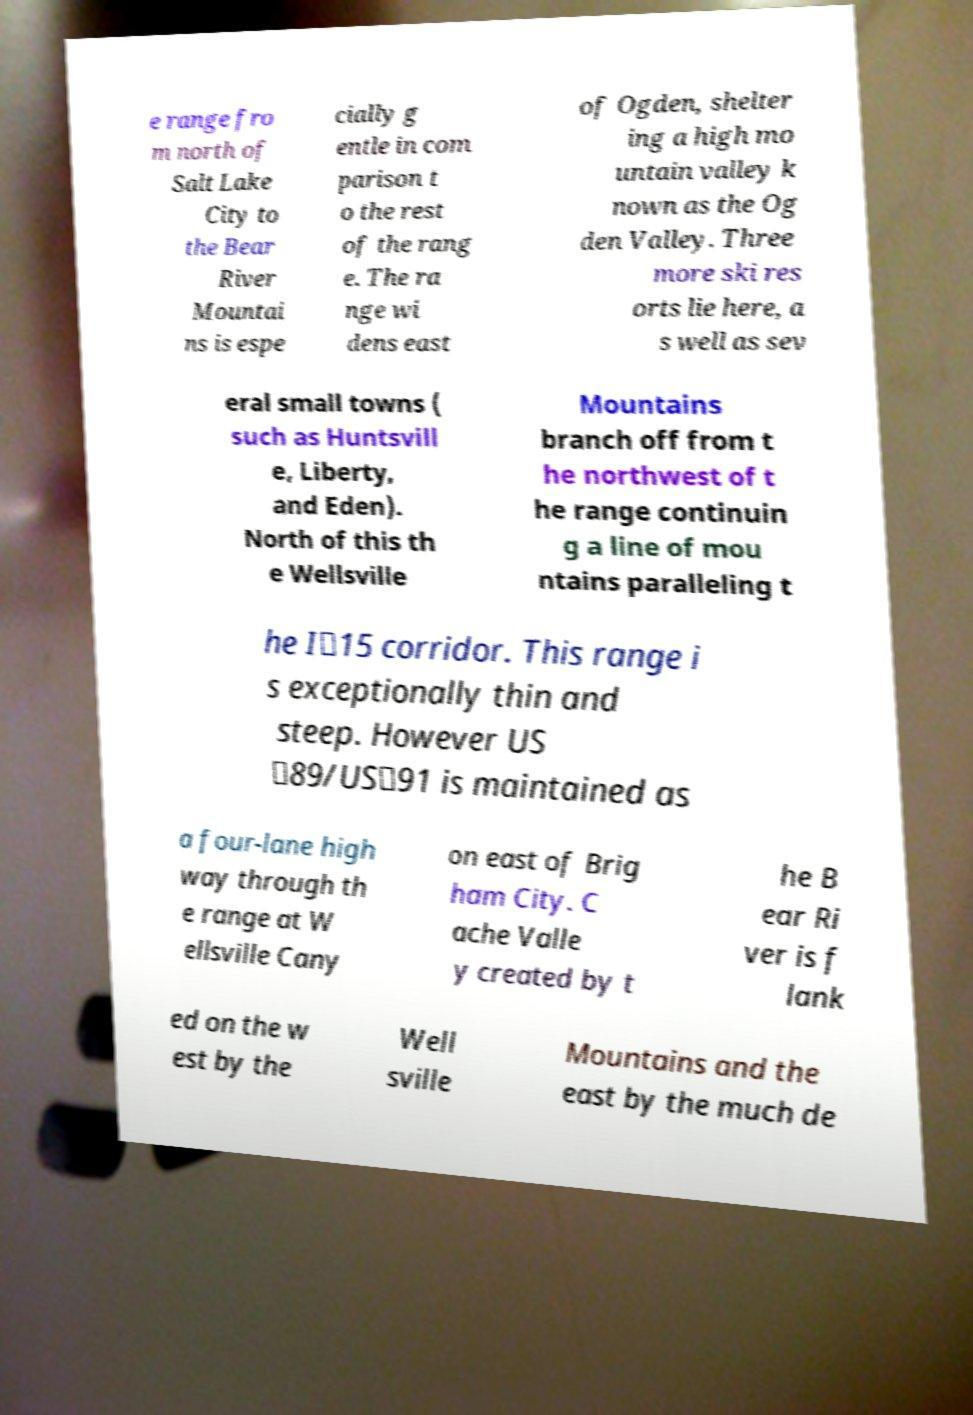Could you extract and type out the text from this image? e range fro m north of Salt Lake City to the Bear River Mountai ns is espe cially g entle in com parison t o the rest of the rang e. The ra nge wi dens east of Ogden, shelter ing a high mo untain valley k nown as the Og den Valley. Three more ski res orts lie here, a s well as sev eral small towns ( such as Huntsvill e, Liberty, and Eden). North of this th e Wellsville Mountains branch off from t he northwest of t he range continuin g a line of mou ntains paralleling t he I‑15 corridor. This range i s exceptionally thin and steep. However US ‑89/US‑91 is maintained as a four-lane high way through th e range at W ellsville Cany on east of Brig ham City. C ache Valle y created by t he B ear Ri ver is f lank ed on the w est by the Well sville Mountains and the east by the much de 